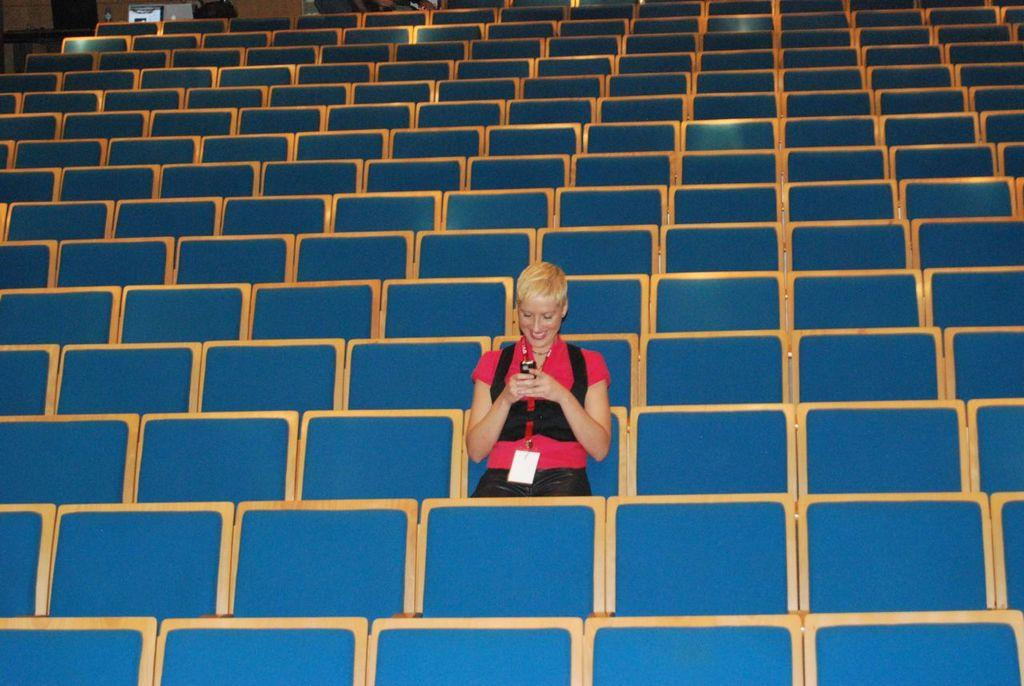Who is present in the image? There is a woman in the image. What is the woman wearing? The woman is wearing a red dress. What object is the woman holding? The woman is holding a mobile phone. What type of identification does the woman have? The woman has an ID card. What can be seen in the background of the image? There is a group of chairs and a door visible in the background of the image. Is there a slope visible in the image? No, there is no slope present in the image. Can you see any matches or coal in the image? No, there are no matches or coal present in the image. 